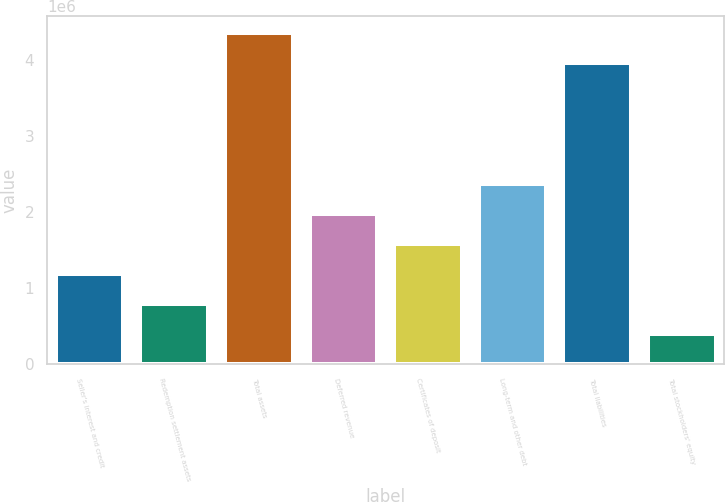<chart> <loc_0><loc_0><loc_500><loc_500><bar_chart><fcel>Seller's interest and credit<fcel>Redemption settlement assets<fcel>Total assets<fcel>Deferred revenue<fcel>Certificates of deposit<fcel>Long-term and other debt<fcel>Total liabilities<fcel>Total stockholders' equity<nl><fcel>1.1867e+06<fcel>790412<fcel>4.35921e+06<fcel>1.97929e+06<fcel>1.583e+06<fcel>2.37558e+06<fcel>3.96292e+06<fcel>394120<nl></chart> 